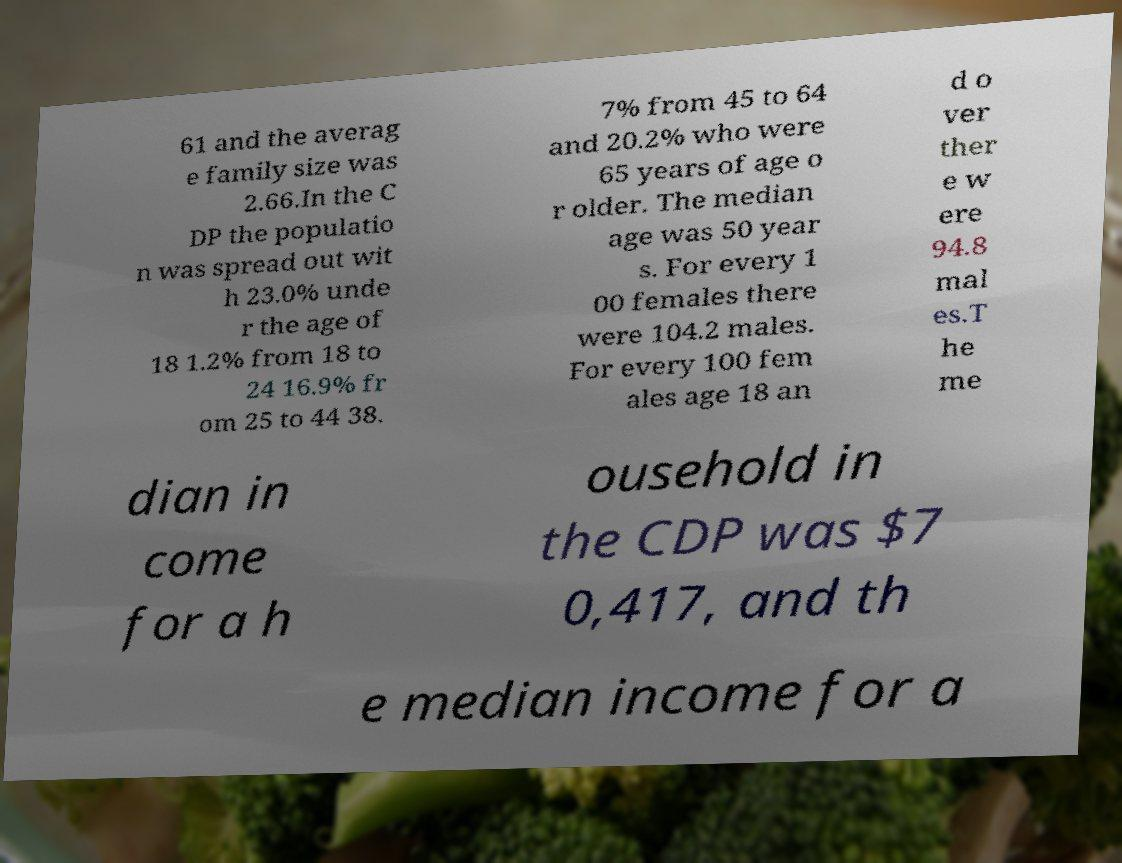What messages or text are displayed in this image? I need them in a readable, typed format. 61 and the averag e family size was 2.66.In the C DP the populatio n was spread out wit h 23.0% unde r the age of 18 1.2% from 18 to 24 16.9% fr om 25 to 44 38. 7% from 45 to 64 and 20.2% who were 65 years of age o r older. The median age was 50 year s. For every 1 00 females there were 104.2 males. For every 100 fem ales age 18 an d o ver ther e w ere 94.8 mal es.T he me dian in come for a h ousehold in the CDP was $7 0,417, and th e median income for a 